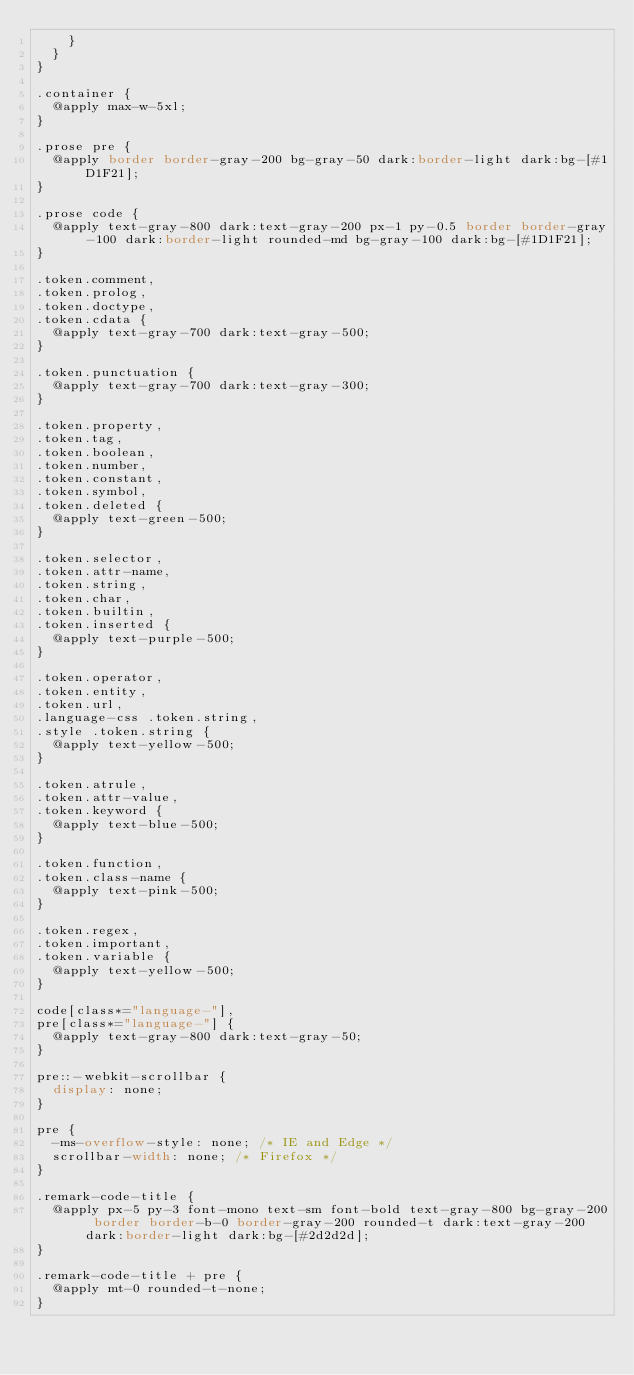Convert code to text. <code><loc_0><loc_0><loc_500><loc_500><_CSS_>    }
  }
}

.container {
  @apply max-w-5xl;
}

.prose pre {
  @apply border border-gray-200 bg-gray-50 dark:border-light dark:bg-[#1D1F21];
}

.prose code {
  @apply text-gray-800 dark:text-gray-200 px-1 py-0.5 border border-gray-100 dark:border-light rounded-md bg-gray-100 dark:bg-[#1D1F21];
}

.token.comment,
.token.prolog,
.token.doctype,
.token.cdata {
  @apply text-gray-700 dark:text-gray-500;
}

.token.punctuation {
  @apply text-gray-700 dark:text-gray-300;
}

.token.property,
.token.tag,
.token.boolean,
.token.number,
.token.constant,
.token.symbol,
.token.deleted {
  @apply text-green-500;
}

.token.selector,
.token.attr-name,
.token.string,
.token.char,
.token.builtin,
.token.inserted {
  @apply text-purple-500;
}

.token.operator,
.token.entity,
.token.url,
.language-css .token.string,
.style .token.string {
  @apply text-yellow-500;
}

.token.atrule,
.token.attr-value,
.token.keyword {
  @apply text-blue-500;
}

.token.function,
.token.class-name {
  @apply text-pink-500;
}

.token.regex,
.token.important,
.token.variable {
  @apply text-yellow-500;
}

code[class*="language-"],
pre[class*="language-"] {
  @apply text-gray-800 dark:text-gray-50;
}

pre::-webkit-scrollbar {
  display: none;
}

pre {
  -ms-overflow-style: none; /* IE and Edge */
  scrollbar-width: none; /* Firefox */
}

.remark-code-title {
  @apply px-5 py-3 font-mono text-sm font-bold text-gray-800 bg-gray-200 border border-b-0 border-gray-200 rounded-t dark:text-gray-200 dark:border-light dark:bg-[#2d2d2d];
}

.remark-code-title + pre {
  @apply mt-0 rounded-t-none;
}
</code> 